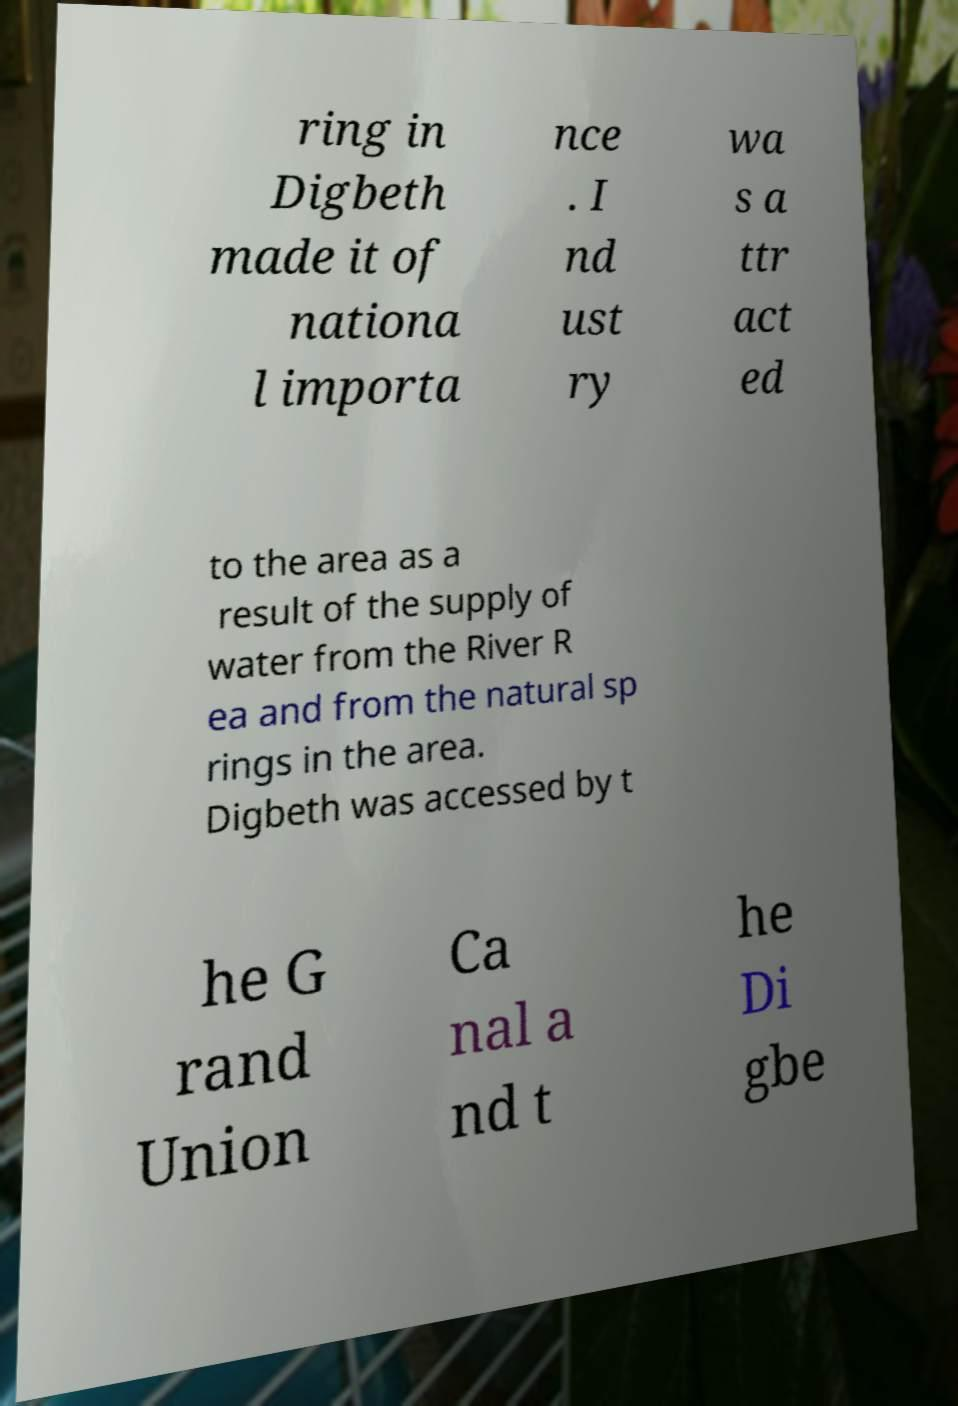Could you assist in decoding the text presented in this image and type it out clearly? ring in Digbeth made it of nationa l importa nce . I nd ust ry wa s a ttr act ed to the area as a result of the supply of water from the River R ea and from the natural sp rings in the area. Digbeth was accessed by t he G rand Union Ca nal a nd t he Di gbe 